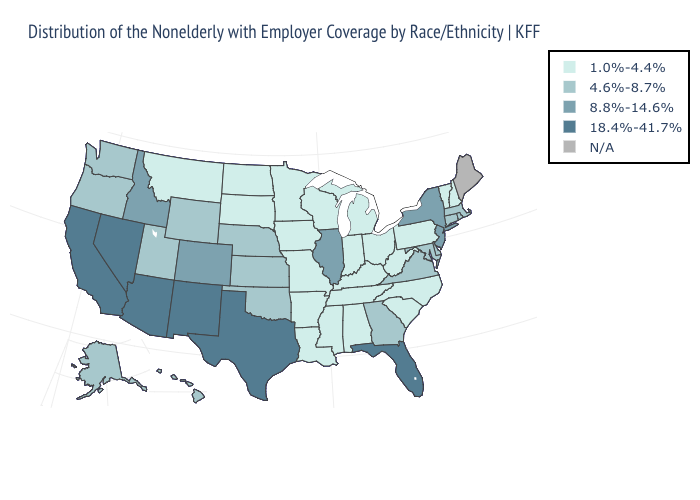Which states hav the highest value in the MidWest?
Give a very brief answer. Illinois. Name the states that have a value in the range 4.6%-8.7%?
Quick response, please. Alaska, Connecticut, Delaware, Georgia, Hawaii, Kansas, Maryland, Massachusetts, Nebraska, Oklahoma, Oregon, Rhode Island, Utah, Virginia, Washington, Wyoming. Name the states that have a value in the range 4.6%-8.7%?
Keep it brief. Alaska, Connecticut, Delaware, Georgia, Hawaii, Kansas, Maryland, Massachusetts, Nebraska, Oklahoma, Oregon, Rhode Island, Utah, Virginia, Washington, Wyoming. What is the value of Arkansas?
Quick response, please. 1.0%-4.4%. Name the states that have a value in the range 18.4%-41.7%?
Give a very brief answer. Arizona, California, Florida, Nevada, New Mexico, Texas. Does New Hampshire have the lowest value in the Northeast?
Quick response, please. Yes. Name the states that have a value in the range 8.8%-14.6%?
Short answer required. Colorado, Idaho, Illinois, New Jersey, New York. Name the states that have a value in the range 8.8%-14.6%?
Quick response, please. Colorado, Idaho, Illinois, New Jersey, New York. Name the states that have a value in the range 8.8%-14.6%?
Keep it brief. Colorado, Idaho, Illinois, New Jersey, New York. Among the states that border Utah , which have the lowest value?
Keep it brief. Wyoming. Which states have the lowest value in the South?
Be succinct. Alabama, Arkansas, Kentucky, Louisiana, Mississippi, North Carolina, South Carolina, Tennessee, West Virginia. Does the first symbol in the legend represent the smallest category?
Answer briefly. Yes. What is the value of New Mexico?
Keep it brief. 18.4%-41.7%. What is the highest value in the USA?
Keep it brief. 18.4%-41.7%. Name the states that have a value in the range 18.4%-41.7%?
Answer briefly. Arizona, California, Florida, Nevada, New Mexico, Texas. 